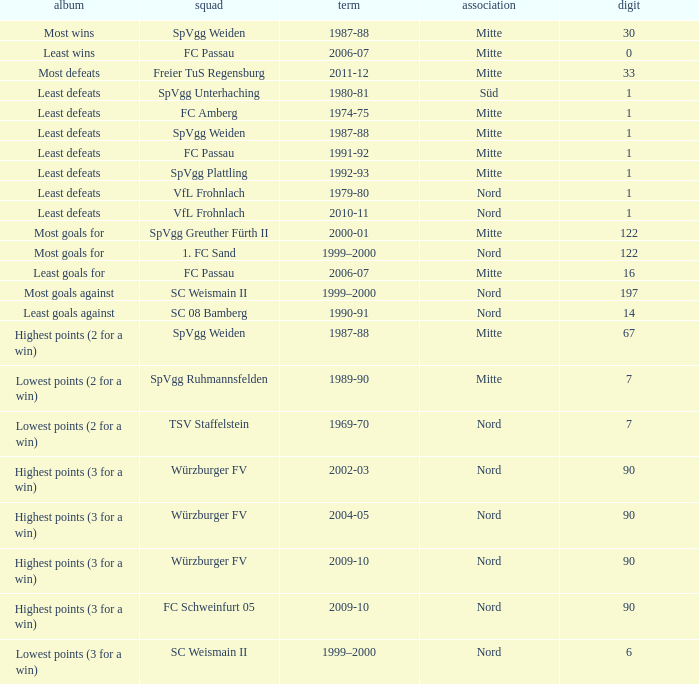What league has a number less than 1? Mitte. 